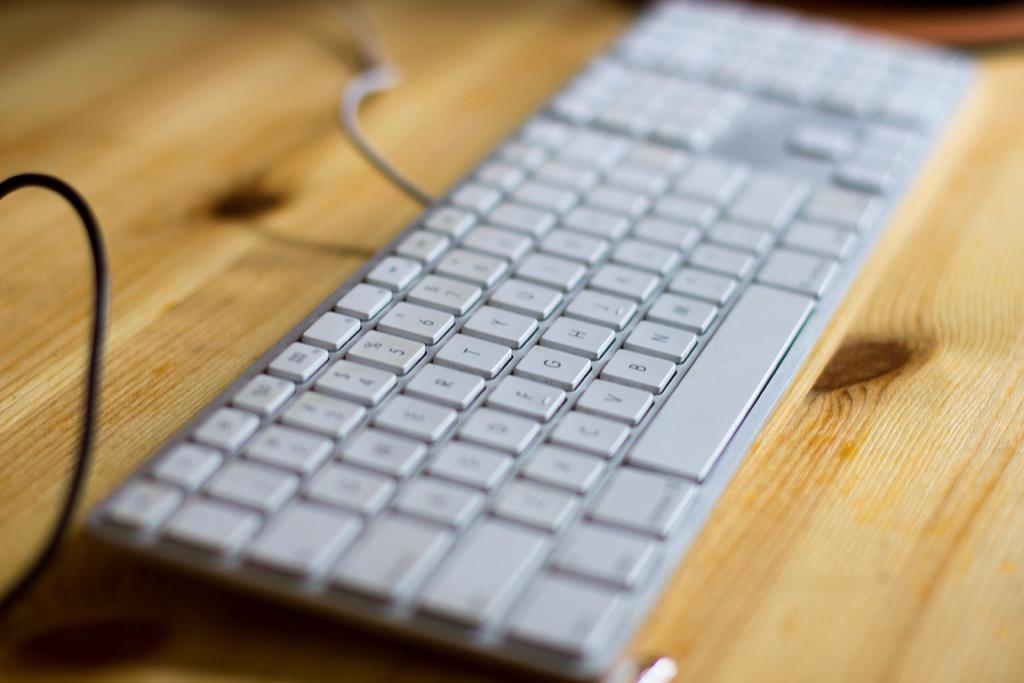<image>
Offer a succinct explanation of the picture presented. A white keyboard is on a wooden desk and has the letters mostly obscured, but the letters R, T, and Y on the upper row of letter keys is clear. 